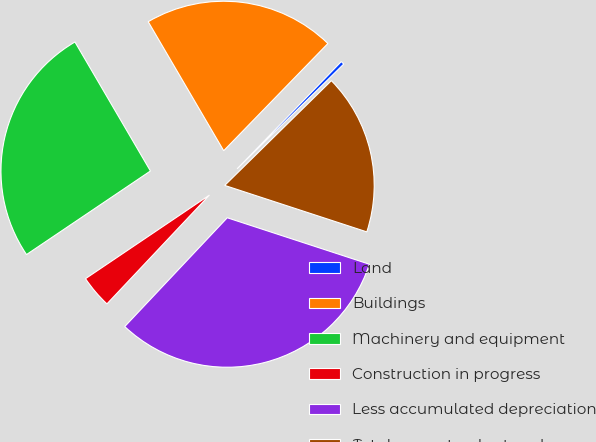Convert chart. <chart><loc_0><loc_0><loc_500><loc_500><pie_chart><fcel>Land<fcel>Buildings<fcel>Machinery and equipment<fcel>Construction in progress<fcel>Less accumulated depreciation<fcel>Total property plant and<nl><fcel>0.37%<fcel>20.7%<fcel>26.02%<fcel>3.53%<fcel>32.0%<fcel>17.39%<nl></chart> 